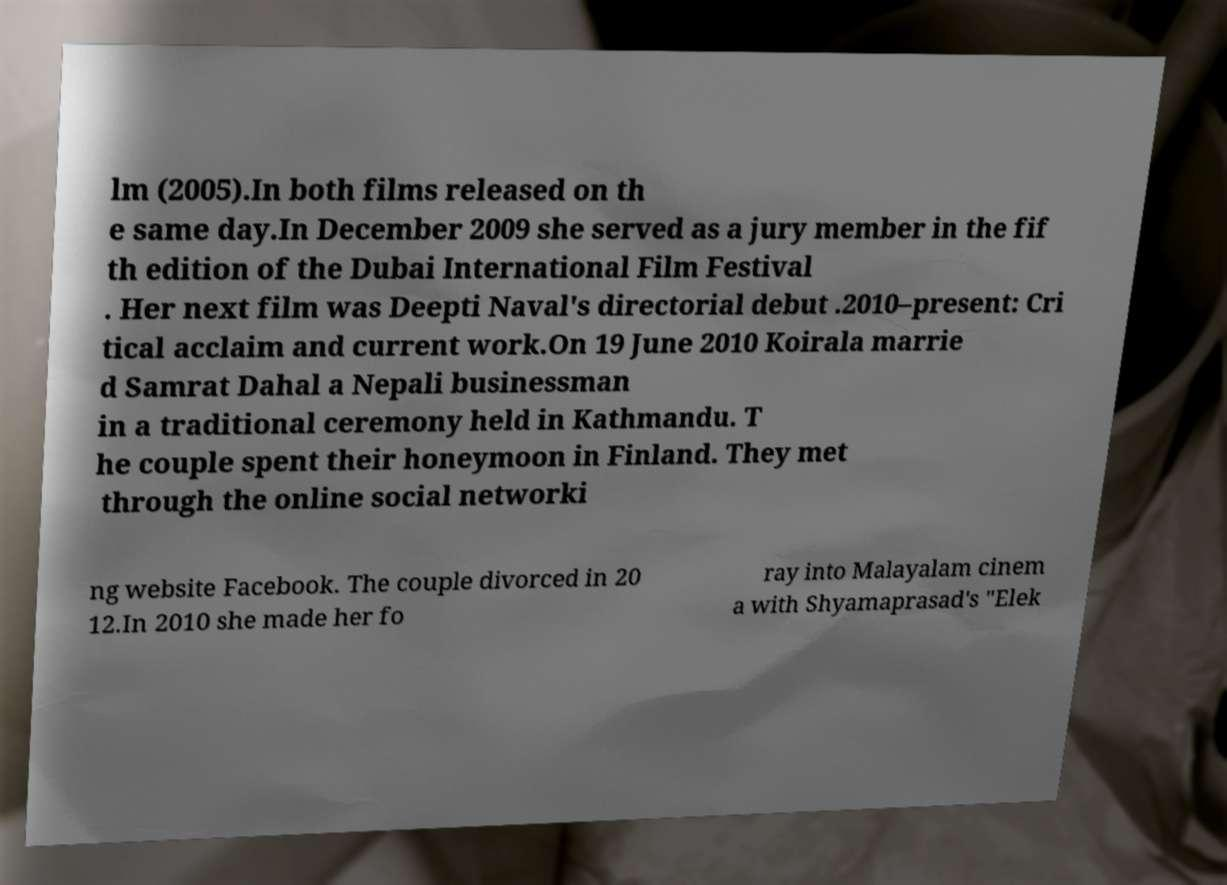Can you accurately transcribe the text from the provided image for me? lm (2005).In both films released on th e same day.In December 2009 she served as a jury member in the fif th edition of the Dubai International Film Festival . Her next film was Deepti Naval's directorial debut .2010–present: Cri tical acclaim and current work.On 19 June 2010 Koirala marrie d Samrat Dahal a Nepali businessman in a traditional ceremony held in Kathmandu. T he couple spent their honeymoon in Finland. They met through the online social networki ng website Facebook. The couple divorced in 20 12.In 2010 she made her fo ray into Malayalam cinem a with Shyamaprasad's "Elek 